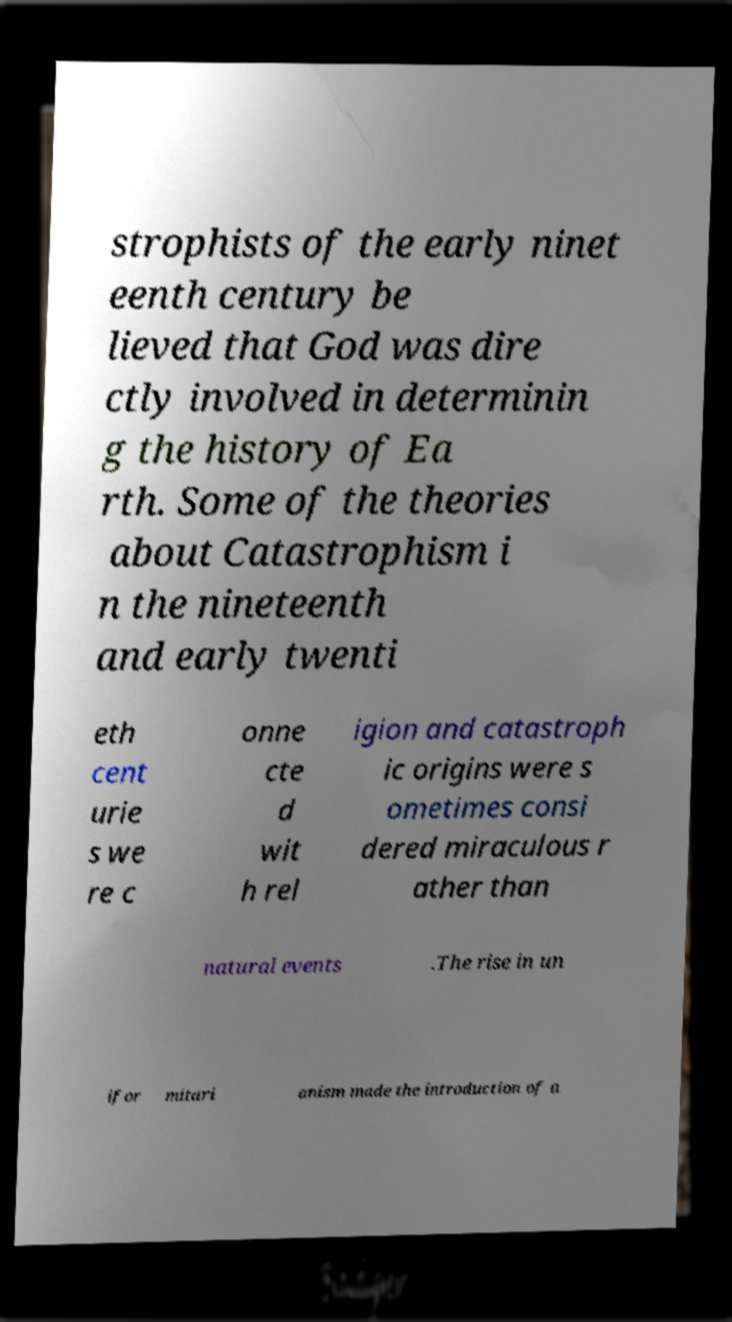Please identify and transcribe the text found in this image. strophists of the early ninet eenth century be lieved that God was dire ctly involved in determinin g the history of Ea rth. Some of the theories about Catastrophism i n the nineteenth and early twenti eth cent urie s we re c onne cte d wit h rel igion and catastroph ic origins were s ometimes consi dered miraculous r ather than natural events .The rise in un ifor mitari anism made the introduction of a 